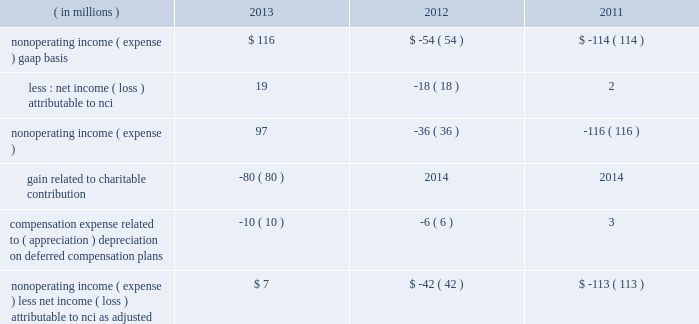Nonoperating income ( expense ) .
Blackrock also uses operating margin , as adjusted , to monitor corporate performance and efficiency and as a benchmark to compare its performance with other companies .
Management uses both gaap and non-gaap financial measures in evaluating blackrock 2019s financial performance .
The non-gaap measure by itself may pose limitations because it does not include all of blackrock 2019s revenues and expenses .
Operating income used for measuring operating margin , as adjusted , is equal to operating income , as adjusted , excluding the impact of closed-end fund launch costs and related commissions .
Management believes the exclusion of such costs and related commissions is useful because these costs can fluctuate considerably and revenues associated with the expenditure of these costs will not fully impact blackrock 2019s results until future periods .
Revenue used for operating margin , as adjusted , excludes distribution and servicing costs paid to related parties and other third parties .
Management believes the exclusion of such costs is useful because it creates consistency in the treatment for certain contracts for similar services , which due to the terms of the contracts , are accounted for under gaap on a net basis within investment advisory , administration fees and securities lending revenue .
Amortization of deferred sales commissions is excluded from revenue used for operating margin measurement , as adjusted , because such costs , over time , substantially offset distribution fee revenue the company earns .
For each of these items , blackrock excludes from revenue used for operating margin , as adjusted , the costs related to each of these items as a proxy for such offsetting revenues .
( b ) nonoperating income ( expense ) , less net income ( loss ) attributable to noncontrolling interests , as adjusted , is presented below .
The compensation expense offset is recorded in operating income .
This compensation expense has been included in nonoperating income ( expense ) , less net income ( loss ) attributable to nci , as adjusted , to offset returns on investments set aside for these plans , which are reported in nonoperating income ( expense ) , gaap basis .
Management believes nonoperating income ( expense ) , less net income ( loss ) attributable to nci , as adjusted , provides comparability of information among reporting periods and is an effective measure for reviewing blackrock 2019s nonoperating contribution to results .
As compensation expense associated with ( appreciation ) depreciation on investments related to certain deferred compensation plans , which is included in operating income , substantially offsets the gain ( loss ) on the investments set aside for these plans , management believes nonoperating income ( expense ) , less net income ( loss ) attributable to nci , as adjusted , provides a useful measure , for both management and investors , of blackrock 2019s nonoperating results that impact book value .
During 2013 , the noncash , nonoperating pre-tax gain of $ 80 million related to the contributed pennymac investment has been excluded from nonoperating income ( expense ) , less net income ( loss ) attributable to nci , as adjusted due to its nonrecurring nature and because the more than offsetting associated charitable contribution expense of $ 124 million is reported in operating income .
( in millions ) 2013 2012 2011 nonoperating income ( expense ) , gaap basis $ 116 $ ( 54 ) $ ( 114 ) less : net income ( loss ) attributable to nci 19 ( 18 ) 2 .
Gain related to charitable contribution ( 80 ) 2014 2014 compensation expense related to ( appreciation ) depreciation on deferred compensation plans ( 10 ) ( 6 ) 3 nonoperating income ( expense ) , less net income ( loss ) attributable to nci , as adjusted $ 7 $ ( 42 ) $ ( 113 ) ( c ) net income attributable to blackrock , as adjusted : management believes net income attributable to blackrock , inc. , as adjusted , and diluted earnings per common share , as adjusted , are useful measures of blackrock 2019s profitability and financial performance .
Net income attributable to blackrock , inc. , as adjusted , equals net income attributable to blackrock , inc. , gaap basis , adjusted for significant nonrecurring items , charges that ultimately will not impact blackrock 2019s book value or certain tax items that do not impact cash flow .
See note ( a ) operating income , as adjusted , and operating margin , as adjusted , for information on the pnc ltip funding obligation , merrill lynch compensation contribution , charitable contribution , u.k .
Lease exit costs , contribution to stifs and restructuring charges .
The 2013 results included a tax benefit of approximately $ 48 million recognized in connection with the charitable contribution .
The tax benefit has been excluded from net income attributable to blackrock , inc. , as adjusted due to the nonrecurring nature of the charitable contribution .
During 2013 , income tax changes included adjustments related to the revaluation of certain deferred income tax liabilities , including the effect of legislation enacted in the united kingdom and domestic state and local income tax changes .
During 2012 , income tax changes included adjustments related to the revaluation of certain deferred income tax liabilities , including the effect of legislation enacted in the united kingdom and the state and local income tax effect resulting from changes in the company 2019s organizational structure .
During 2011 , income tax changes included adjustments related to the revaluation of certain deferred income tax liabilities due to a state tax election and enacted u.k. , japan , u.s .
State and local tax legislation .
The resulting decrease in income taxes has been excluded from net income attributable to blackrock , inc. , as adjusted , as these items will not have a cash flow impact and to ensure comparability among periods presented. .
What is the tax benefit as a percentage of nonoperating income ( expense ) on a gaap basis in 2013? 
Computations: (48 / 116)
Answer: 0.41379. Nonoperating income ( expense ) .
Blackrock also uses operating margin , as adjusted , to monitor corporate performance and efficiency and as a benchmark to compare its performance with other companies .
Management uses both gaap and non-gaap financial measures in evaluating blackrock 2019s financial performance .
The non-gaap measure by itself may pose limitations because it does not include all of blackrock 2019s revenues and expenses .
Operating income used for measuring operating margin , as adjusted , is equal to operating income , as adjusted , excluding the impact of closed-end fund launch costs and related commissions .
Management believes the exclusion of such costs and related commissions is useful because these costs can fluctuate considerably and revenues associated with the expenditure of these costs will not fully impact blackrock 2019s results until future periods .
Revenue used for operating margin , as adjusted , excludes distribution and servicing costs paid to related parties and other third parties .
Management believes the exclusion of such costs is useful because it creates consistency in the treatment for certain contracts for similar services , which due to the terms of the contracts , are accounted for under gaap on a net basis within investment advisory , administration fees and securities lending revenue .
Amortization of deferred sales commissions is excluded from revenue used for operating margin measurement , as adjusted , because such costs , over time , substantially offset distribution fee revenue the company earns .
For each of these items , blackrock excludes from revenue used for operating margin , as adjusted , the costs related to each of these items as a proxy for such offsetting revenues .
( b ) nonoperating income ( expense ) , less net income ( loss ) attributable to noncontrolling interests , as adjusted , is presented below .
The compensation expense offset is recorded in operating income .
This compensation expense has been included in nonoperating income ( expense ) , less net income ( loss ) attributable to nci , as adjusted , to offset returns on investments set aside for these plans , which are reported in nonoperating income ( expense ) , gaap basis .
Management believes nonoperating income ( expense ) , less net income ( loss ) attributable to nci , as adjusted , provides comparability of information among reporting periods and is an effective measure for reviewing blackrock 2019s nonoperating contribution to results .
As compensation expense associated with ( appreciation ) depreciation on investments related to certain deferred compensation plans , which is included in operating income , substantially offsets the gain ( loss ) on the investments set aside for these plans , management believes nonoperating income ( expense ) , less net income ( loss ) attributable to nci , as adjusted , provides a useful measure , for both management and investors , of blackrock 2019s nonoperating results that impact book value .
During 2013 , the noncash , nonoperating pre-tax gain of $ 80 million related to the contributed pennymac investment has been excluded from nonoperating income ( expense ) , less net income ( loss ) attributable to nci , as adjusted due to its nonrecurring nature and because the more than offsetting associated charitable contribution expense of $ 124 million is reported in operating income .
( in millions ) 2013 2012 2011 nonoperating income ( expense ) , gaap basis $ 116 $ ( 54 ) $ ( 114 ) less : net income ( loss ) attributable to nci 19 ( 18 ) 2 .
Gain related to charitable contribution ( 80 ) 2014 2014 compensation expense related to ( appreciation ) depreciation on deferred compensation plans ( 10 ) ( 6 ) 3 nonoperating income ( expense ) , less net income ( loss ) attributable to nci , as adjusted $ 7 $ ( 42 ) $ ( 113 ) ( c ) net income attributable to blackrock , as adjusted : management believes net income attributable to blackrock , inc. , as adjusted , and diluted earnings per common share , as adjusted , are useful measures of blackrock 2019s profitability and financial performance .
Net income attributable to blackrock , inc. , as adjusted , equals net income attributable to blackrock , inc. , gaap basis , adjusted for significant nonrecurring items , charges that ultimately will not impact blackrock 2019s book value or certain tax items that do not impact cash flow .
See note ( a ) operating income , as adjusted , and operating margin , as adjusted , for information on the pnc ltip funding obligation , merrill lynch compensation contribution , charitable contribution , u.k .
Lease exit costs , contribution to stifs and restructuring charges .
The 2013 results included a tax benefit of approximately $ 48 million recognized in connection with the charitable contribution .
The tax benefit has been excluded from net income attributable to blackrock , inc. , as adjusted due to the nonrecurring nature of the charitable contribution .
During 2013 , income tax changes included adjustments related to the revaluation of certain deferred income tax liabilities , including the effect of legislation enacted in the united kingdom and domestic state and local income tax changes .
During 2012 , income tax changes included adjustments related to the revaluation of certain deferred income tax liabilities , including the effect of legislation enacted in the united kingdom and the state and local income tax effect resulting from changes in the company 2019s organizational structure .
During 2011 , income tax changes included adjustments related to the revaluation of certain deferred income tax liabilities due to a state tax election and enacted u.k. , japan , u.s .
State and local tax legislation .
The resulting decrease in income taxes has been excluded from net income attributable to blackrock , inc. , as adjusted , as these items will not have a cash flow impact and to ensure comparability among periods presented. .
What is the nonoperating income ( expense ) less net income ( loss ) attributable to nci as adjusted as a percentage of nonoperating income ( expense ) on a gaap basis in 2013? 
Computations: (7 / 116)
Answer: 0.06034. Nonoperating income ( expense ) .
Blackrock also uses operating margin , as adjusted , to monitor corporate performance and efficiency and as a benchmark to compare its performance with other companies .
Management uses both gaap and non-gaap financial measures in evaluating blackrock 2019s financial performance .
The non-gaap measure by itself may pose limitations because it does not include all of blackrock 2019s revenues and expenses .
Operating income used for measuring operating margin , as adjusted , is equal to operating income , as adjusted , excluding the impact of closed-end fund launch costs and related commissions .
Management believes the exclusion of such costs and related commissions is useful because these costs can fluctuate considerably and revenues associated with the expenditure of these costs will not fully impact blackrock 2019s results until future periods .
Revenue used for operating margin , as adjusted , excludes distribution and servicing costs paid to related parties and other third parties .
Management believes the exclusion of such costs is useful because it creates consistency in the treatment for certain contracts for similar services , which due to the terms of the contracts , are accounted for under gaap on a net basis within investment advisory , administration fees and securities lending revenue .
Amortization of deferred sales commissions is excluded from revenue used for operating margin measurement , as adjusted , because such costs , over time , substantially offset distribution fee revenue the company earns .
For each of these items , blackrock excludes from revenue used for operating margin , as adjusted , the costs related to each of these items as a proxy for such offsetting revenues .
( b ) nonoperating income ( expense ) , less net income ( loss ) attributable to noncontrolling interests , as adjusted , is presented below .
The compensation expense offset is recorded in operating income .
This compensation expense has been included in nonoperating income ( expense ) , less net income ( loss ) attributable to nci , as adjusted , to offset returns on investments set aside for these plans , which are reported in nonoperating income ( expense ) , gaap basis .
Management believes nonoperating income ( expense ) , less net income ( loss ) attributable to nci , as adjusted , provides comparability of information among reporting periods and is an effective measure for reviewing blackrock 2019s nonoperating contribution to results .
As compensation expense associated with ( appreciation ) depreciation on investments related to certain deferred compensation plans , which is included in operating income , substantially offsets the gain ( loss ) on the investments set aside for these plans , management believes nonoperating income ( expense ) , less net income ( loss ) attributable to nci , as adjusted , provides a useful measure , for both management and investors , of blackrock 2019s nonoperating results that impact book value .
During 2013 , the noncash , nonoperating pre-tax gain of $ 80 million related to the contributed pennymac investment has been excluded from nonoperating income ( expense ) , less net income ( loss ) attributable to nci , as adjusted due to its nonrecurring nature and because the more than offsetting associated charitable contribution expense of $ 124 million is reported in operating income .
( in millions ) 2013 2012 2011 nonoperating income ( expense ) , gaap basis $ 116 $ ( 54 ) $ ( 114 ) less : net income ( loss ) attributable to nci 19 ( 18 ) 2 .
Gain related to charitable contribution ( 80 ) 2014 2014 compensation expense related to ( appreciation ) depreciation on deferred compensation plans ( 10 ) ( 6 ) 3 nonoperating income ( expense ) , less net income ( loss ) attributable to nci , as adjusted $ 7 $ ( 42 ) $ ( 113 ) ( c ) net income attributable to blackrock , as adjusted : management believes net income attributable to blackrock , inc. , as adjusted , and diluted earnings per common share , as adjusted , are useful measures of blackrock 2019s profitability and financial performance .
Net income attributable to blackrock , inc. , as adjusted , equals net income attributable to blackrock , inc. , gaap basis , adjusted for significant nonrecurring items , charges that ultimately will not impact blackrock 2019s book value or certain tax items that do not impact cash flow .
See note ( a ) operating income , as adjusted , and operating margin , as adjusted , for information on the pnc ltip funding obligation , merrill lynch compensation contribution , charitable contribution , u.k .
Lease exit costs , contribution to stifs and restructuring charges .
The 2013 results included a tax benefit of approximately $ 48 million recognized in connection with the charitable contribution .
The tax benefit has been excluded from net income attributable to blackrock , inc. , as adjusted due to the nonrecurring nature of the charitable contribution .
During 2013 , income tax changes included adjustments related to the revaluation of certain deferred income tax liabilities , including the effect of legislation enacted in the united kingdom and domestic state and local income tax changes .
During 2012 , income tax changes included adjustments related to the revaluation of certain deferred income tax liabilities , including the effect of legislation enacted in the united kingdom and the state and local income tax effect resulting from changes in the company 2019s organizational structure .
During 2011 , income tax changes included adjustments related to the revaluation of certain deferred income tax liabilities due to a state tax election and enacted u.k. , japan , u.s .
State and local tax legislation .
The resulting decrease in income taxes has been excluded from net income attributable to blackrock , inc. , as adjusted , as these items will not have a cash flow impact and to ensure comparability among periods presented. .
By what amount is the non-operating income gaap basis higher in 2012 compare to 2011? 
Computations: (-54 - -114)
Answer: 60.0. 